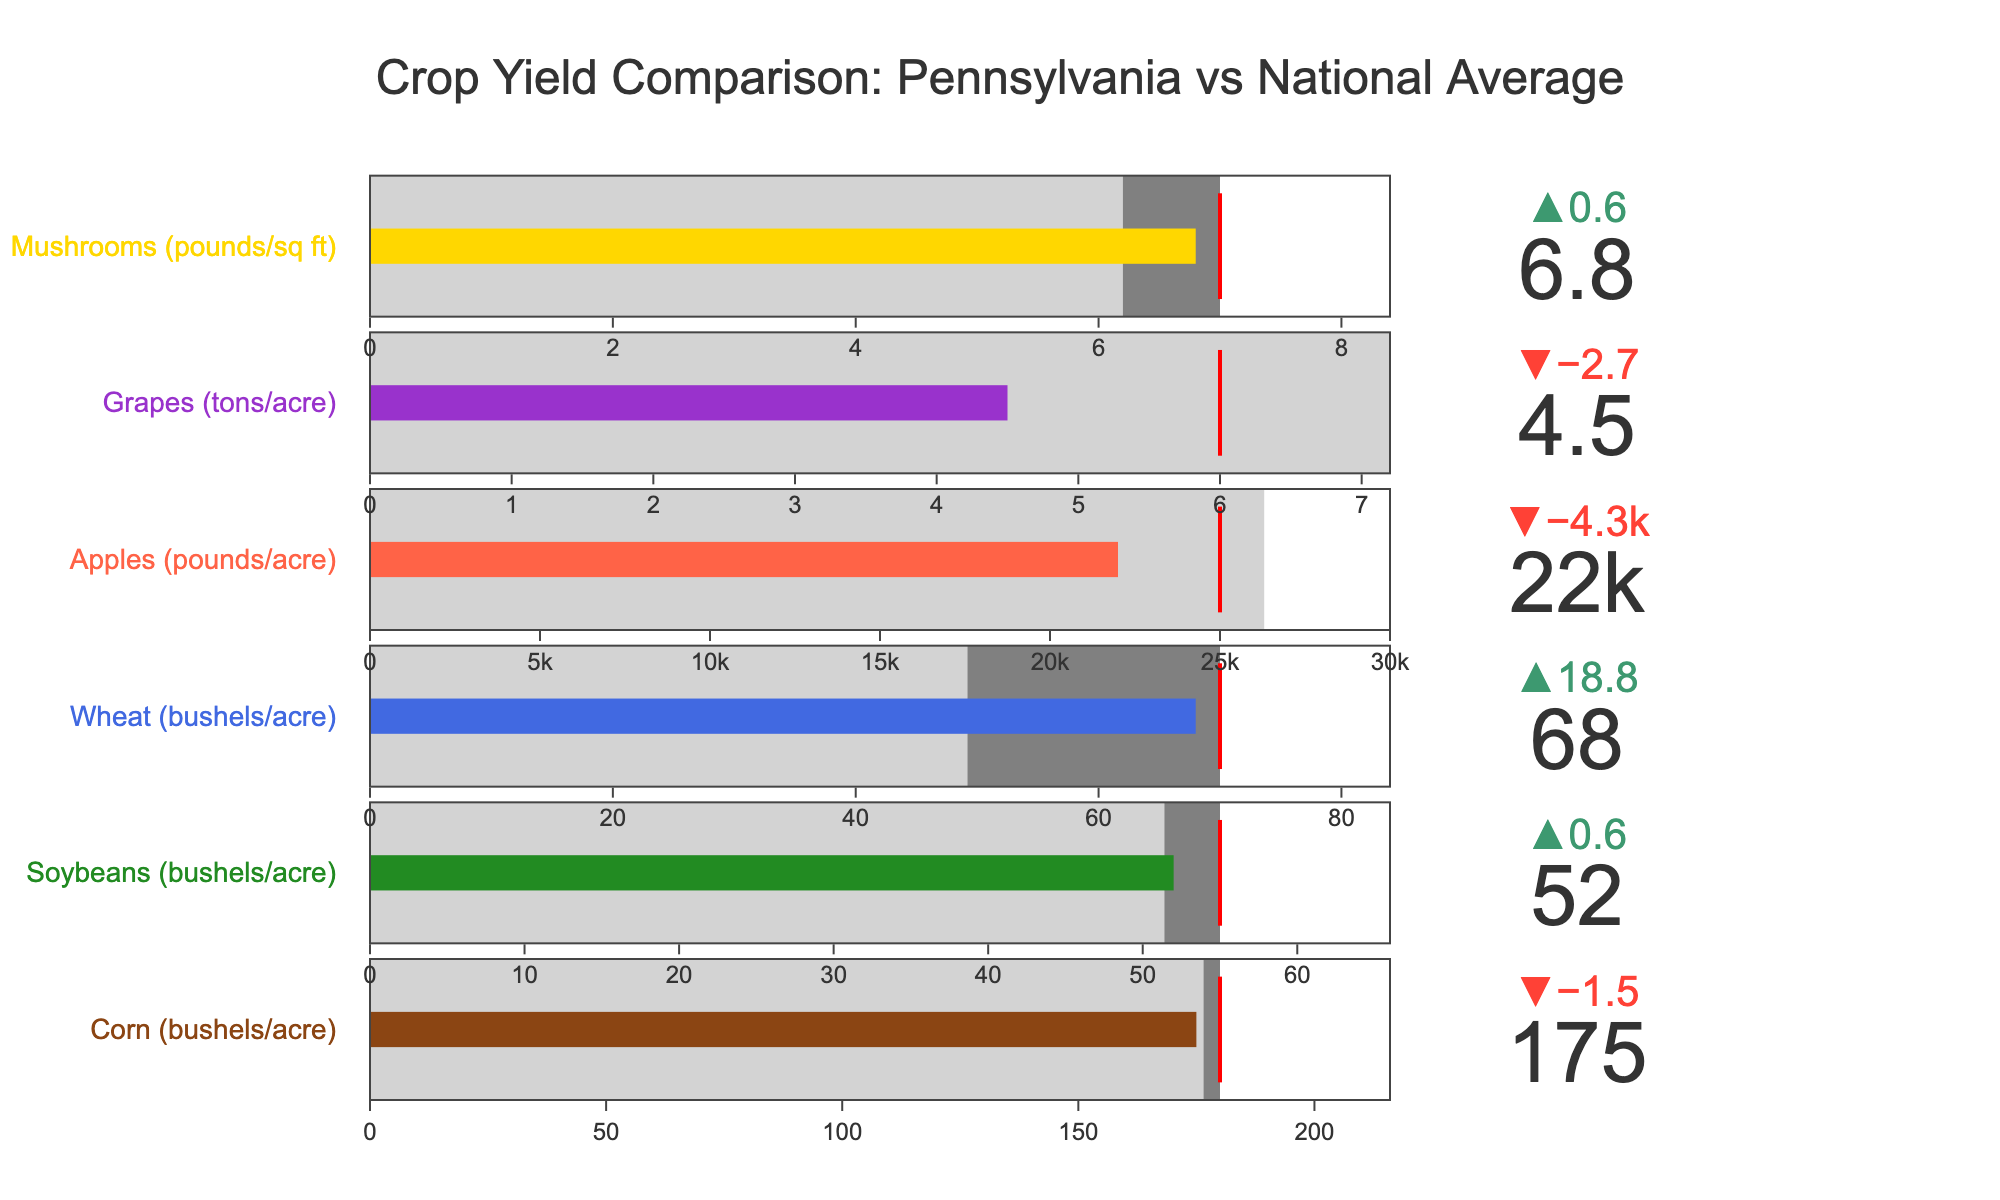What's the title of the figure? The title is usually located at the top of the figure, prominently displayed to summarize the information. In this case, the title is "Crop Yield Comparison: Pennsylvania vs National Average."
Answer: Crop Yield Comparison: Pennsylvania vs National Average How does the Pennsylvania corn yield compare to the national average? The bullet for Corn shows a value of 175 bushels/acre for Pennsylvania and a reference (national average) line at 176.5 bushels/acre.
Answer: Slightly lower What is the target yield for wheat in Pennsylvania? The target yield is marked with a red line on the bullet chart. For wheat, this line is shown at 70 bushels/acre.
Answer: 70 bushels/acre Which crop has the highest yield difference favoring Pennsylvania over the national average? By inspecting the bullet indicators and delta positions, Wheat shows the highest positive difference between PA Yield (68 bushels/acre) and the US Average (49.2 bushels/acre).
Answer: Wheat Which crop is performing below its target in Pennsylvania? By observing the positions of the PA Yield relative to the red threshold lines (targets), Corn (175/180), Apples (22000/25000), and Grapes (4.5/6) are noticed.
Answer: Corn, Apples, Grapes How much higher is the Pennsylvania soybean yield compared to the national average? By looking at the delta position for Soybeans, the PA Yield is 52 bushels/acre while the US Average is 51.4 bushels/acre. The difference is 52 - 51.4 = 0.6 bushels/acre.
Answer: 0.6 bushels/acre Which crop in Pennsylvania is closest to its national average yield? Comparing the bullet values and reference lines, Corn's PA Yield (175 bushels/acre) is closest to the national average (176.5 bushels/acre).
Answer: Corn How does the yield of mushrooms in Pennsylvania compare to the target? The PA Yield for Mushrooms is represented at 6.8 pounds/sq ft, while the target is 7 pounds/sq ft.
Answer: Slightly below What is the US average yield for grapes? The US Average for grapes is marked by the light gray area ending at 7.2 tons/acre.
Answer: 7.2 tons/acre 